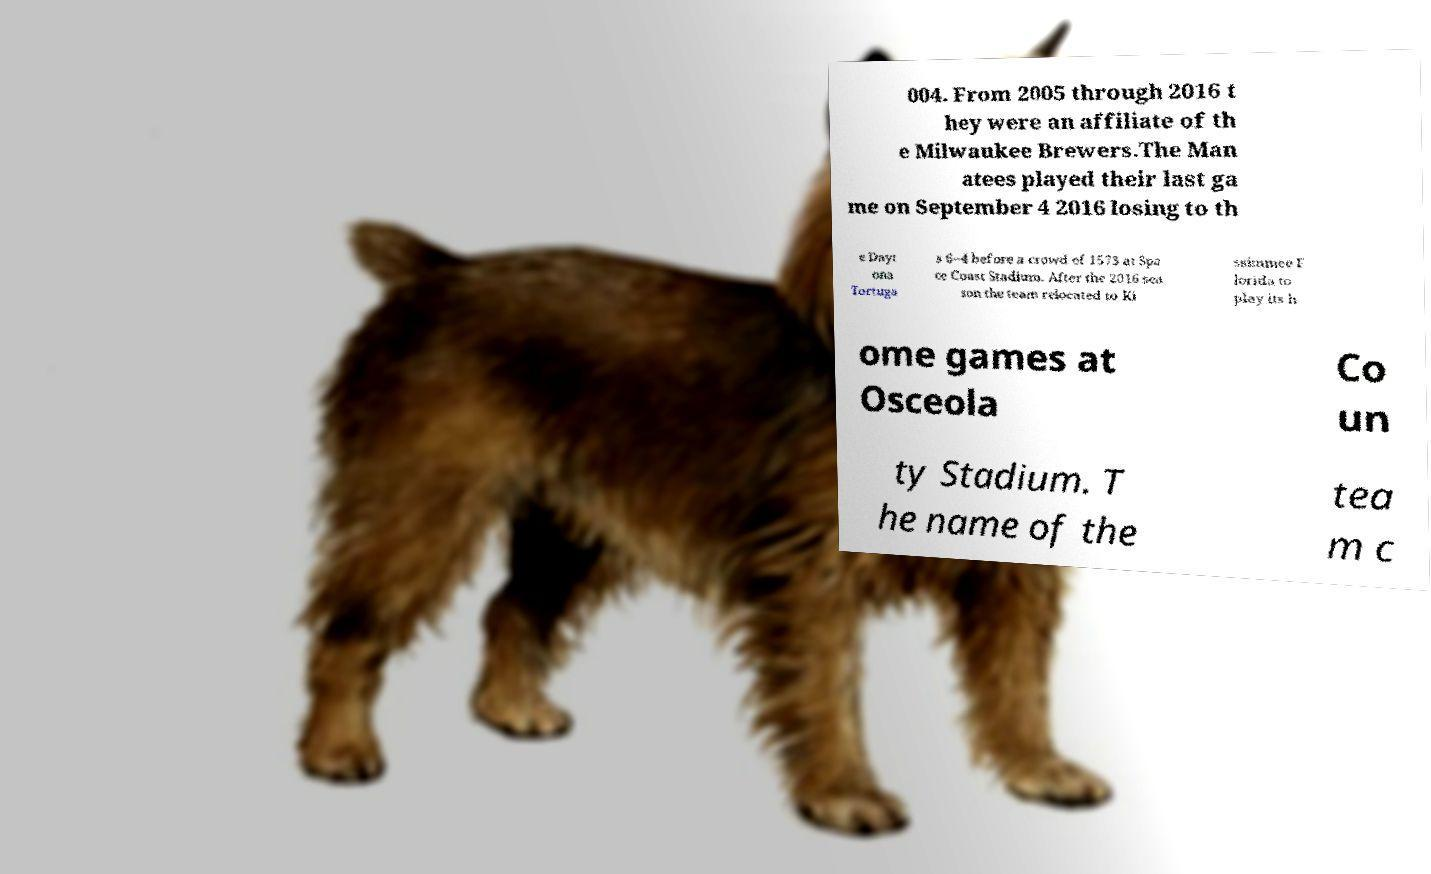I need the written content from this picture converted into text. Can you do that? 004. From 2005 through 2016 t hey were an affiliate of th e Milwaukee Brewers.The Man atees played their last ga me on September 4 2016 losing to th e Dayt ona Tortuga s 6–4 before a crowd of 1573 at Spa ce Coast Stadium. After the 2016 sea son the team relocated to Ki ssimmee F lorida to play its h ome games at Osceola Co un ty Stadium. T he name of the tea m c 